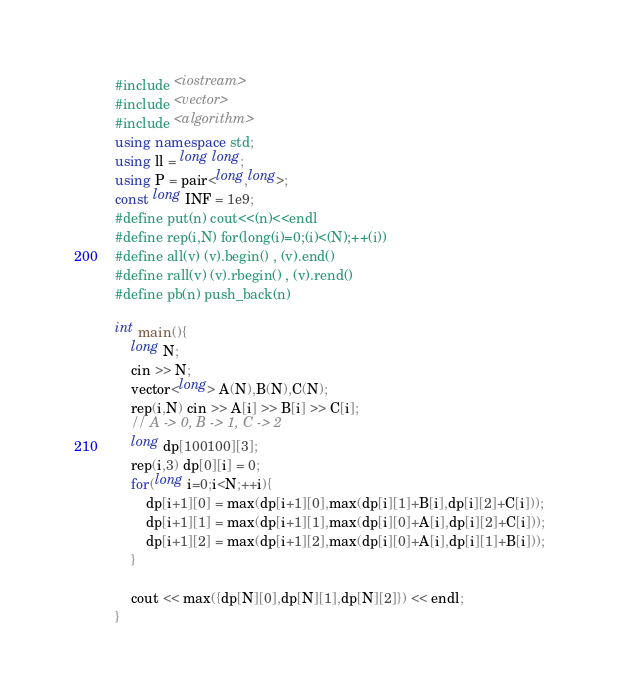Convert code to text. <code><loc_0><loc_0><loc_500><loc_500><_C++_>#include <iostream>
#include <vector>
#include <algorithm>
using namespace std;
using ll = long long;
using P = pair<long,long>;
const long INF = 1e9;
#define put(n) cout<<(n)<<endl
#define rep(i,N) for(long(i)=0;(i)<(N);++(i))
#define all(v) (v).begin() , (v).end()
#define rall(v) (v).rbegin() , (v).rend()
#define pb(n) push_back(n)

int main(){
    long N;
    cin >> N;
    vector<long> A(N),B(N),C(N);
    rep(i,N) cin >> A[i] >> B[i] >> C[i];
    // A -> 0, B -> 1, C -> 2
    long dp[100100][3];
    rep(i,3) dp[0][i] = 0;
    for(long i=0;i<N;++i){
        dp[i+1][0] = max(dp[i+1][0],max(dp[i][1]+B[i],dp[i][2]+C[i])); 
        dp[i+1][1] = max(dp[i+1][1],max(dp[i][0]+A[i],dp[i][2]+C[i])); 
        dp[i+1][2] = max(dp[i+1][2],max(dp[i][0]+A[i],dp[i][1]+B[i])); 
    }

    cout << max({dp[N][0],dp[N][1],dp[N][2]}) << endl;
}</code> 